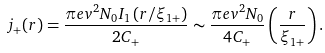<formula> <loc_0><loc_0><loc_500><loc_500>j _ { + } ( r ) = \frac { \pi e v ^ { 2 } N _ { 0 } I _ { 1 } \left ( r / \xi _ { 1 + } \right ) } { 2 C _ { + } } \sim \frac { \pi e v ^ { 2 } N _ { 0 } } { 4 C _ { + } } \left ( \frac { r } { \xi _ { 1 + } } \right ) .</formula> 